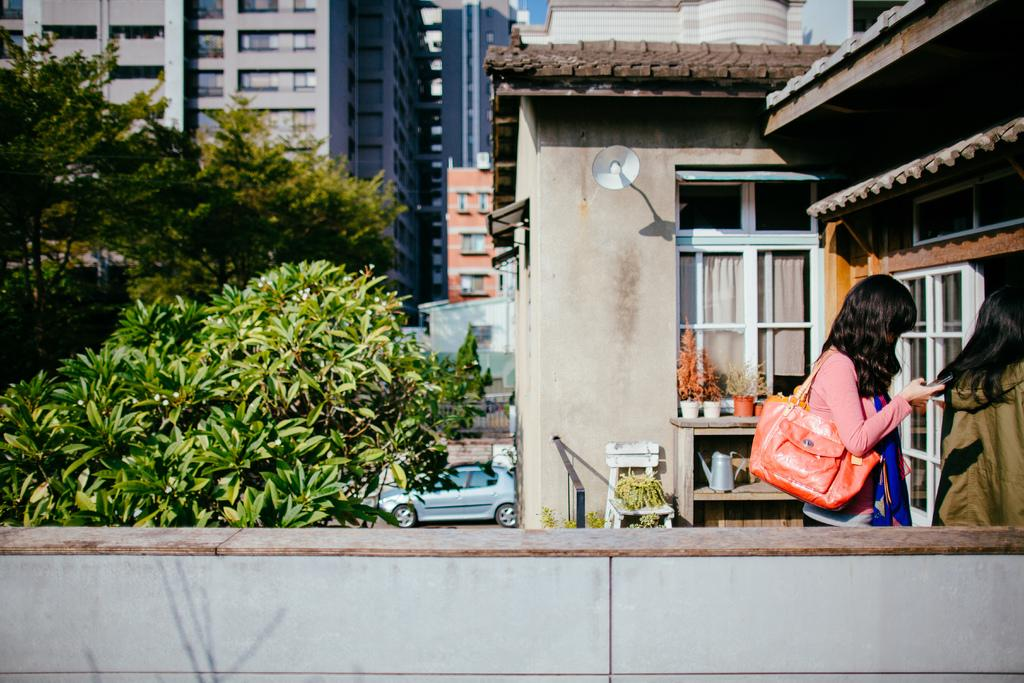How many women are present in the image? There are two women in the image. What can be seen in the background of the image? There are trees and buildings in the background of the image. What disease is the woman on the left suffering from in the image? There is no indication of any disease in the image; it only shows two women and the background. 